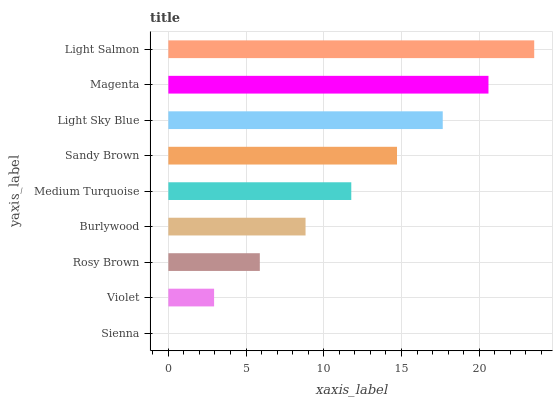Is Sienna the minimum?
Answer yes or no. Yes. Is Light Salmon the maximum?
Answer yes or no. Yes. Is Violet the minimum?
Answer yes or no. No. Is Violet the maximum?
Answer yes or no. No. Is Violet greater than Sienna?
Answer yes or no. Yes. Is Sienna less than Violet?
Answer yes or no. Yes. Is Sienna greater than Violet?
Answer yes or no. No. Is Violet less than Sienna?
Answer yes or no. No. Is Medium Turquoise the high median?
Answer yes or no. Yes. Is Medium Turquoise the low median?
Answer yes or no. Yes. Is Rosy Brown the high median?
Answer yes or no. No. Is Light Salmon the low median?
Answer yes or no. No. 